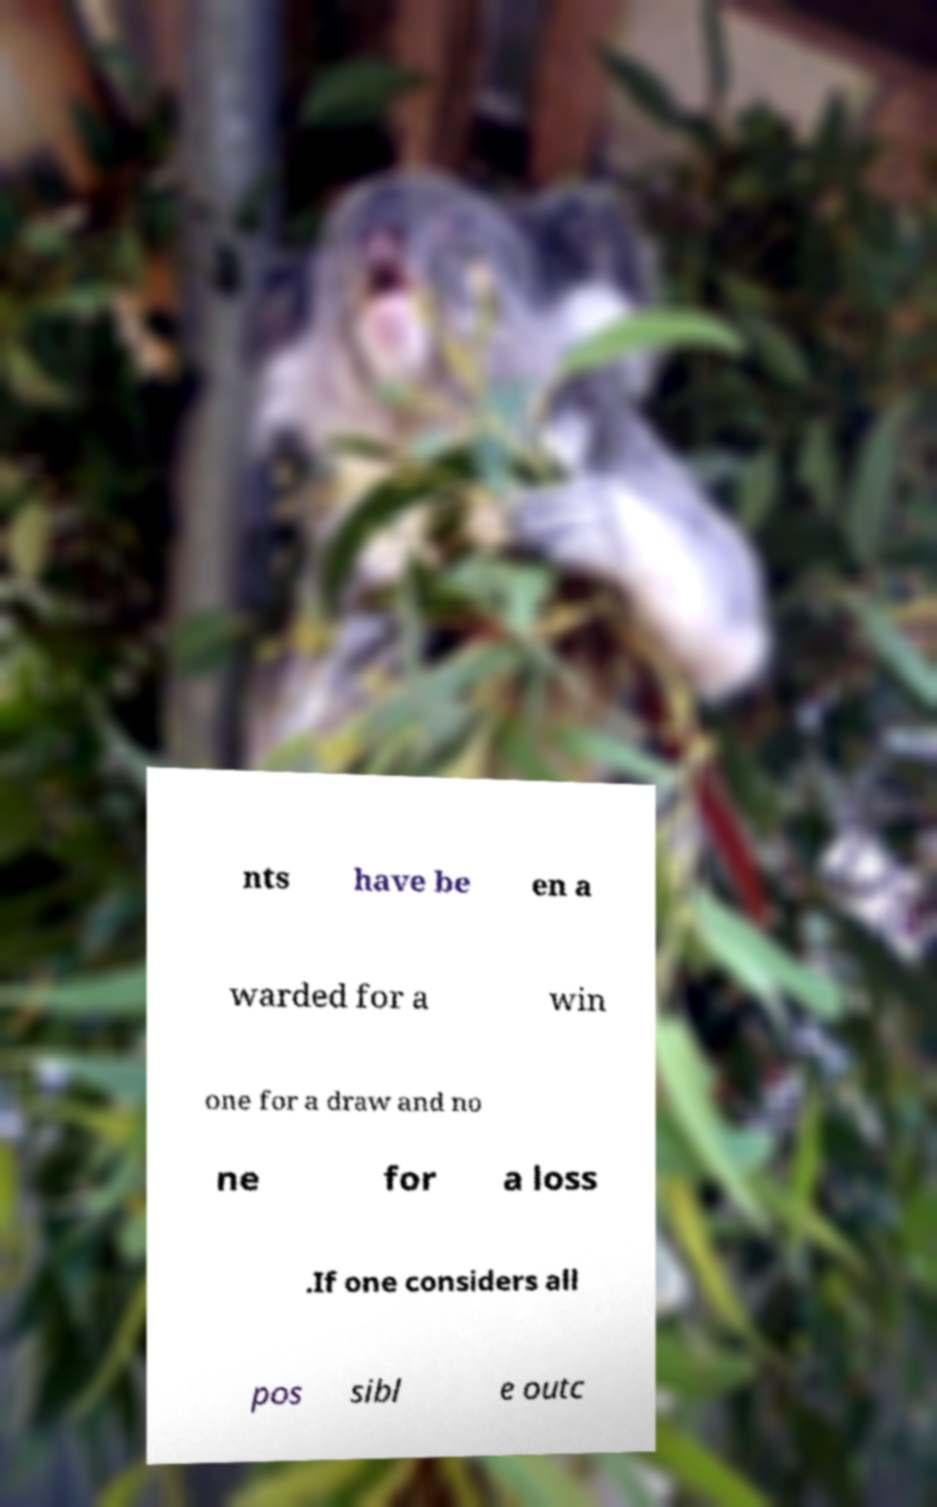I need the written content from this picture converted into text. Can you do that? nts have be en a warded for a win one for a draw and no ne for a loss .If one considers all pos sibl e outc 